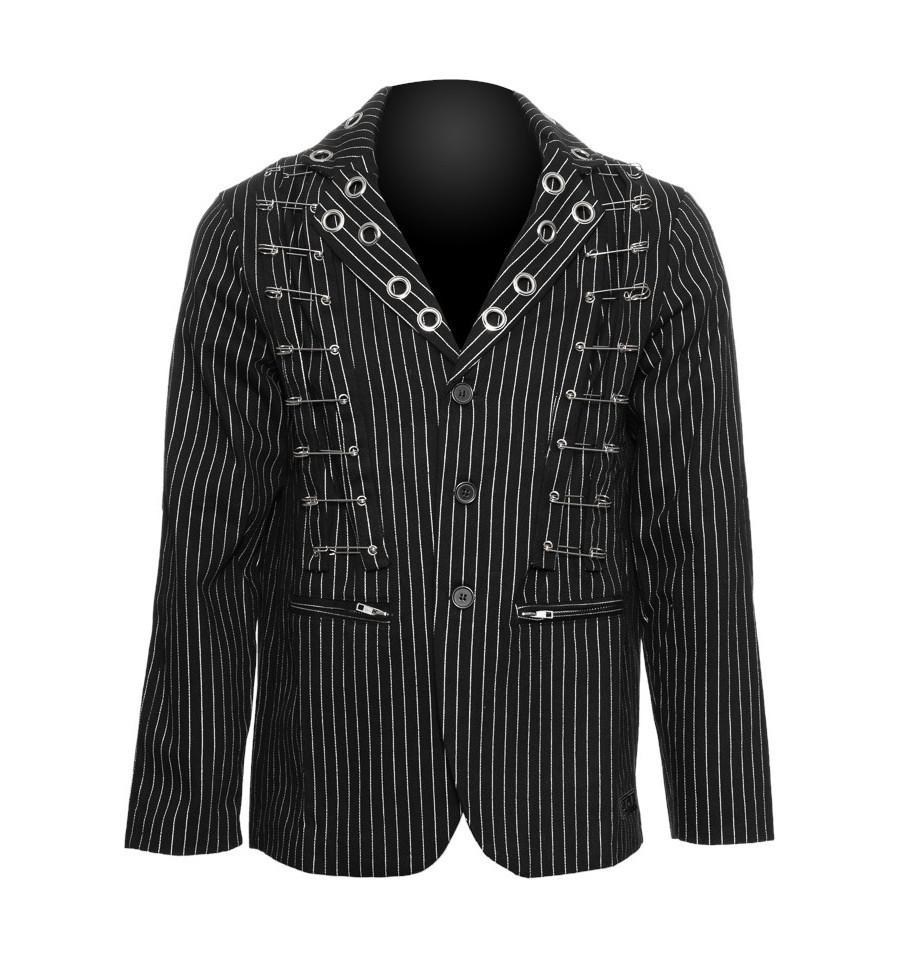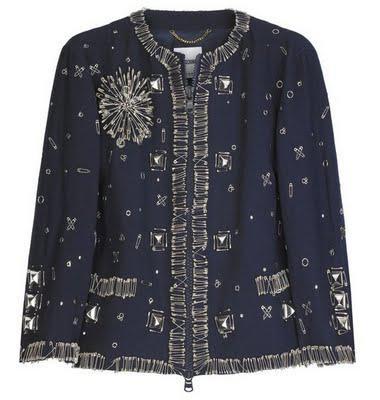The first image is the image on the left, the second image is the image on the right. Analyze the images presented: Is the assertion "The images show the backs of coats." valid? Answer yes or no. No. The first image is the image on the left, the second image is the image on the right. Assess this claim about the two images: "At least one jacket is sleeveless.". Correct or not? Answer yes or no. No. 